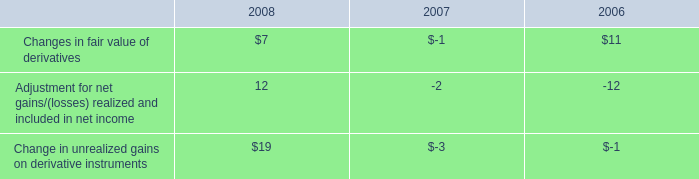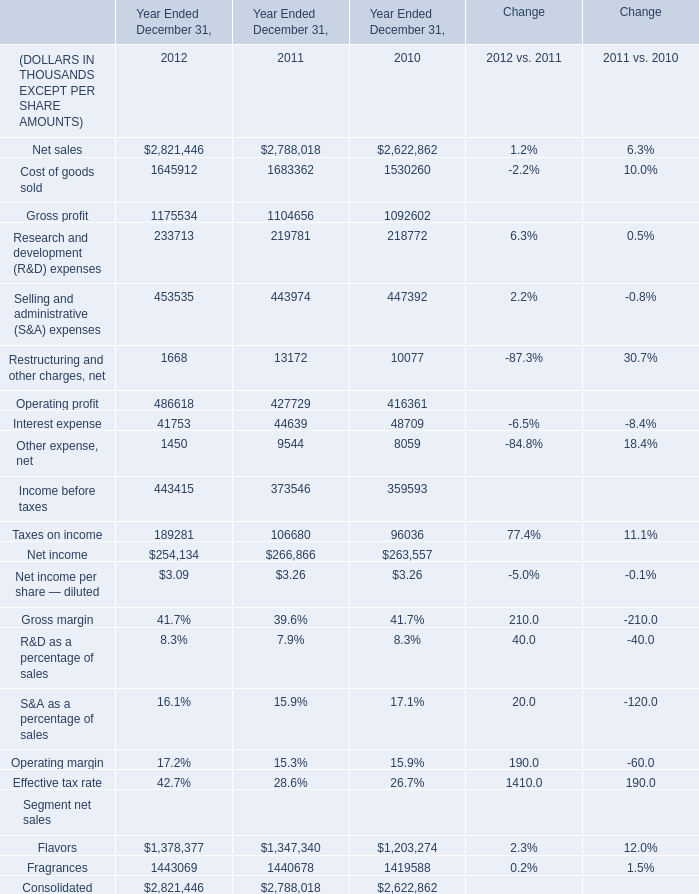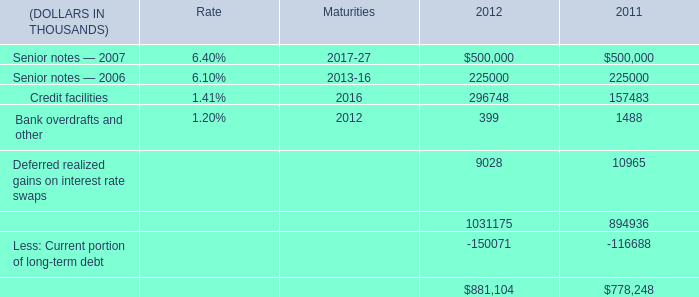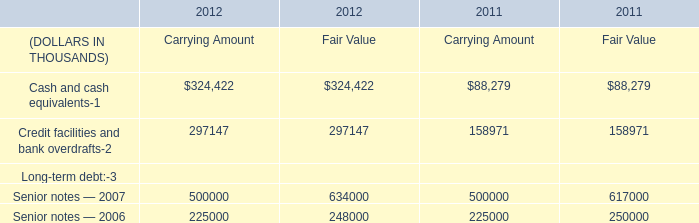What is the average amount of Senior notes — 2007 of 2011, and Other expense, net of Year Ended December 31, 2011 ? 
Computations: ((500000.0 + 9544.0) / 2)
Answer: 254772.0. 